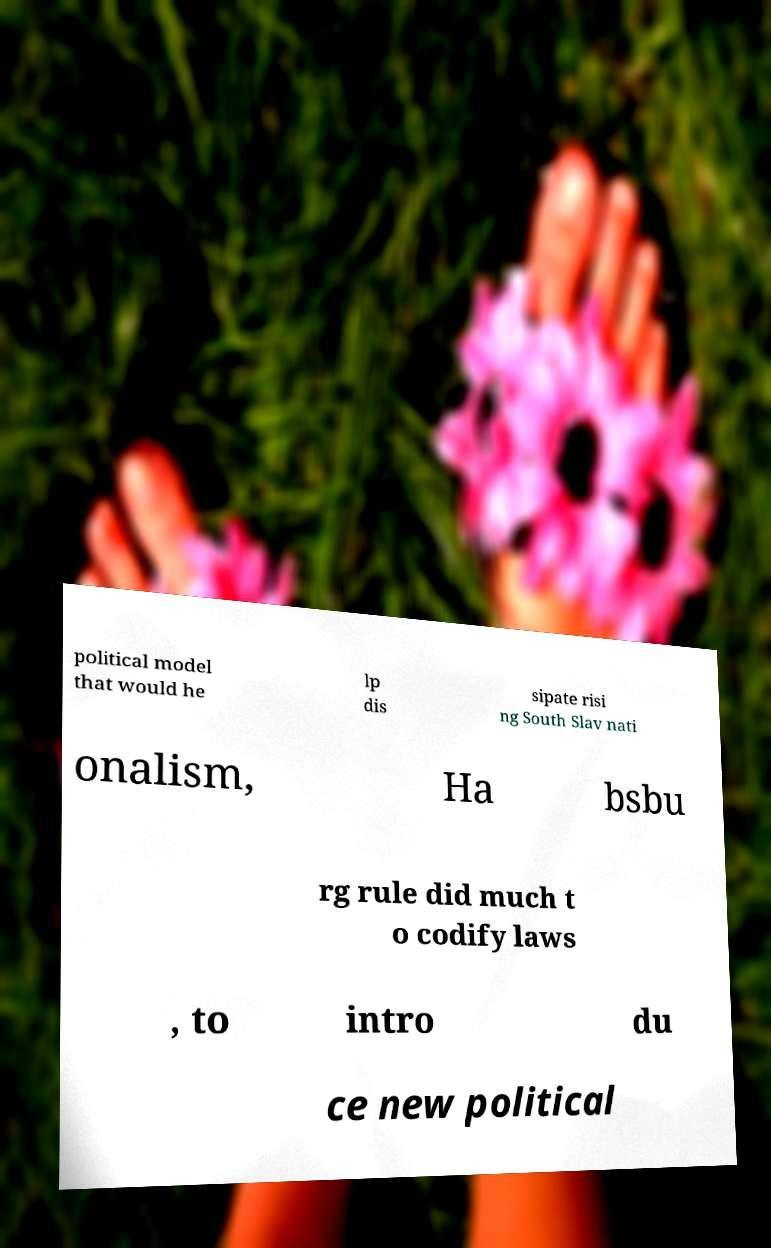Can you accurately transcribe the text from the provided image for me? political model that would he lp dis sipate risi ng South Slav nati onalism, Ha bsbu rg rule did much t o codify laws , to intro du ce new political 